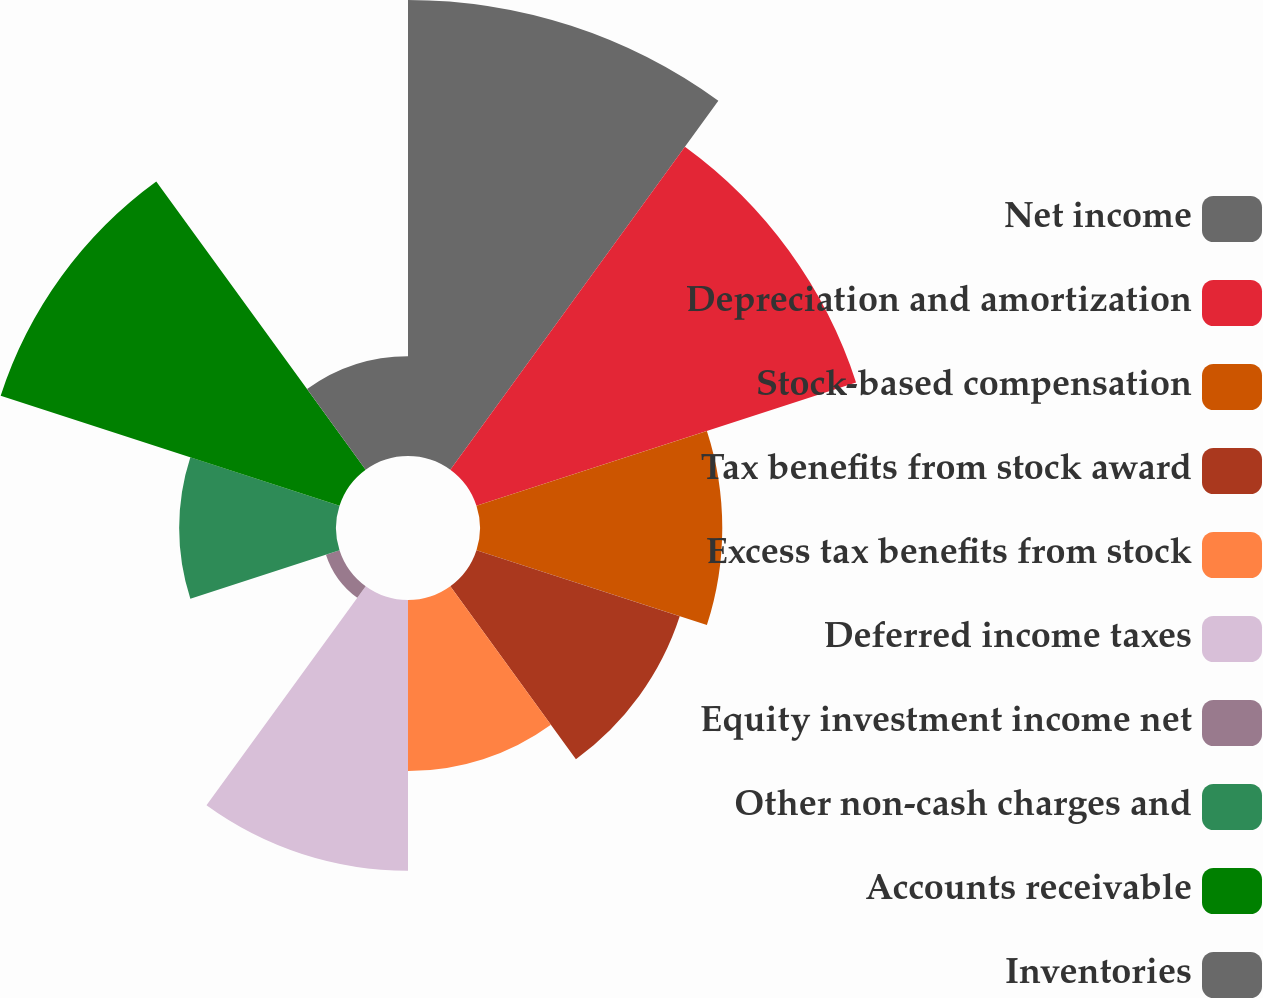Convert chart. <chart><loc_0><loc_0><loc_500><loc_500><pie_chart><fcel>Net income<fcel>Depreciation and amortization<fcel>Stock-based compensation<fcel>Tax benefits from stock award<fcel>Excess tax benefits from stock<fcel>Deferred income taxes<fcel>Equity investment income net<fcel>Other non-cash charges and<fcel>Accounts receivable<fcel>Inventories<nl><fcel>19.16%<fcel>16.77%<fcel>10.18%<fcel>8.98%<fcel>7.19%<fcel>11.38%<fcel>0.6%<fcel>6.59%<fcel>14.97%<fcel>4.19%<nl></chart> 